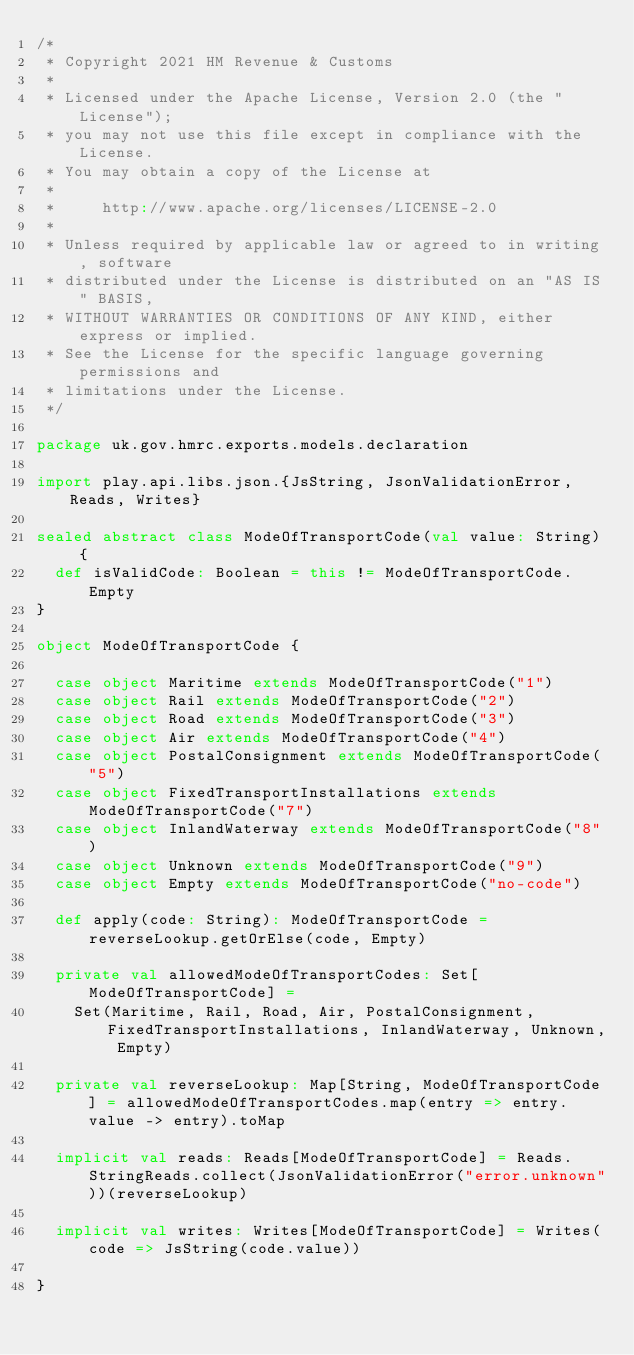<code> <loc_0><loc_0><loc_500><loc_500><_Scala_>/*
 * Copyright 2021 HM Revenue & Customs
 *
 * Licensed under the Apache License, Version 2.0 (the "License");
 * you may not use this file except in compliance with the License.
 * You may obtain a copy of the License at
 *
 *     http://www.apache.org/licenses/LICENSE-2.0
 *
 * Unless required by applicable law or agreed to in writing, software
 * distributed under the License is distributed on an "AS IS" BASIS,
 * WITHOUT WARRANTIES OR CONDITIONS OF ANY KIND, either express or implied.
 * See the License for the specific language governing permissions and
 * limitations under the License.
 */

package uk.gov.hmrc.exports.models.declaration

import play.api.libs.json.{JsString, JsonValidationError, Reads, Writes}

sealed abstract class ModeOfTransportCode(val value: String) {
  def isValidCode: Boolean = this != ModeOfTransportCode.Empty
}

object ModeOfTransportCode {

  case object Maritime extends ModeOfTransportCode("1")
  case object Rail extends ModeOfTransportCode("2")
  case object Road extends ModeOfTransportCode("3")
  case object Air extends ModeOfTransportCode("4")
  case object PostalConsignment extends ModeOfTransportCode("5")
  case object FixedTransportInstallations extends ModeOfTransportCode("7")
  case object InlandWaterway extends ModeOfTransportCode("8")
  case object Unknown extends ModeOfTransportCode("9")
  case object Empty extends ModeOfTransportCode("no-code")

  def apply(code: String): ModeOfTransportCode = reverseLookup.getOrElse(code, Empty)

  private val allowedModeOfTransportCodes: Set[ModeOfTransportCode] =
    Set(Maritime, Rail, Road, Air, PostalConsignment, FixedTransportInstallations, InlandWaterway, Unknown, Empty)

  private val reverseLookup: Map[String, ModeOfTransportCode] = allowedModeOfTransportCodes.map(entry => entry.value -> entry).toMap

  implicit val reads: Reads[ModeOfTransportCode] = Reads.StringReads.collect(JsonValidationError("error.unknown"))(reverseLookup)

  implicit val writes: Writes[ModeOfTransportCode] = Writes(code => JsString(code.value))

}
</code> 